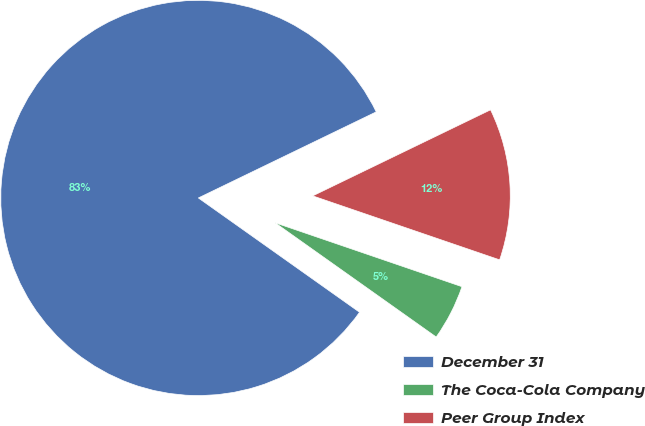Convert chart to OTSL. <chart><loc_0><loc_0><loc_500><loc_500><pie_chart><fcel>December 31<fcel>The Coca-Cola Company<fcel>Peer Group Index<nl><fcel>83.01%<fcel>4.57%<fcel>12.42%<nl></chart> 